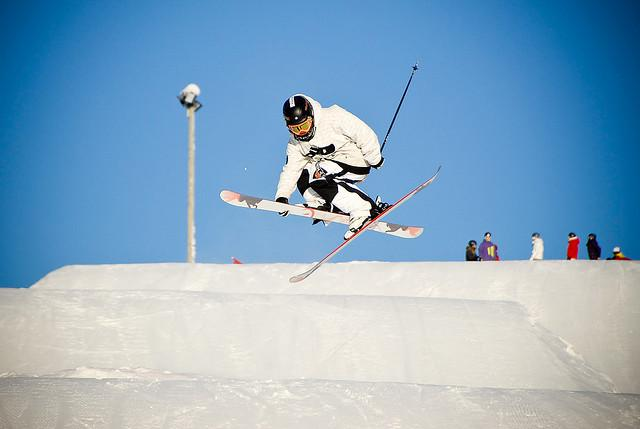Why is the man holding onto the ski? keep below 